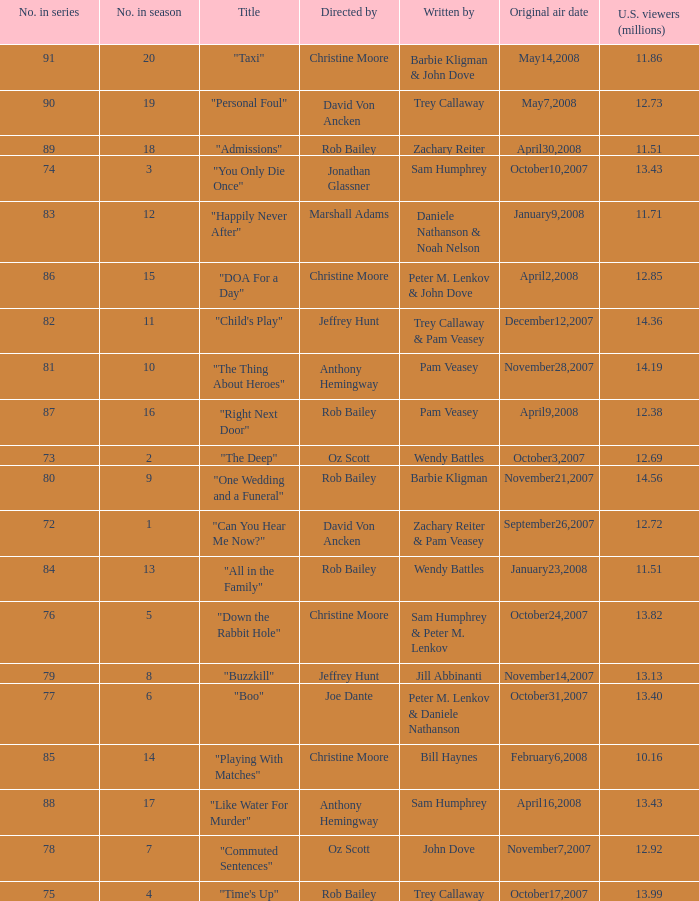How many millions of U.S. viewers watched the episode directed by Rob Bailey and written by Pam Veasey? 12.38. Write the full table. {'header': ['No. in series', 'No. in season', 'Title', 'Directed by', 'Written by', 'Original air date', 'U.S. viewers (millions)'], 'rows': [['91', '20', '"Taxi"', 'Christine Moore', 'Barbie Kligman & John Dove', 'May14,2008', '11.86'], ['90', '19', '"Personal Foul"', 'David Von Ancken', 'Trey Callaway', 'May7,2008', '12.73'], ['89', '18', '"Admissions"', 'Rob Bailey', 'Zachary Reiter', 'April30,2008', '11.51'], ['74', '3', '"You Only Die Once"', 'Jonathan Glassner', 'Sam Humphrey', 'October10,2007', '13.43'], ['83', '12', '"Happily Never After"', 'Marshall Adams', 'Daniele Nathanson & Noah Nelson', 'January9,2008', '11.71'], ['86', '15', '"DOA For a Day"', 'Christine Moore', 'Peter M. Lenkov & John Dove', 'April2,2008', '12.85'], ['82', '11', '"Child\'s Play"', 'Jeffrey Hunt', 'Trey Callaway & Pam Veasey', 'December12,2007', '14.36'], ['81', '10', '"The Thing About Heroes"', 'Anthony Hemingway', 'Pam Veasey', 'November28,2007', '14.19'], ['87', '16', '"Right Next Door"', 'Rob Bailey', 'Pam Veasey', 'April9,2008', '12.38'], ['73', '2', '"The Deep"', 'Oz Scott', 'Wendy Battles', 'October3,2007', '12.69'], ['80', '9', '"One Wedding and a Funeral"', 'Rob Bailey', 'Barbie Kligman', 'November21,2007', '14.56'], ['72', '1', '"Can You Hear Me Now?"', 'David Von Ancken', 'Zachary Reiter & Pam Veasey', 'September26,2007', '12.72'], ['84', '13', '"All in the Family"', 'Rob Bailey', 'Wendy Battles', 'January23,2008', '11.51'], ['76', '5', '"Down the Rabbit Hole"', 'Christine Moore', 'Sam Humphrey & Peter M. Lenkov', 'October24,2007', '13.82'], ['79', '8', '"Buzzkill"', 'Jeffrey Hunt', 'Jill Abbinanti', 'November14,2007', '13.13'], ['77', '6', '"Boo"', 'Joe Dante', 'Peter M. Lenkov & Daniele Nathanson', 'October31,2007', '13.40'], ['85', '14', '"Playing With Matches"', 'Christine Moore', 'Bill Haynes', 'February6,2008', '10.16'], ['88', '17', '"Like Water For Murder"', 'Anthony Hemingway', 'Sam Humphrey', 'April16,2008', '13.43'], ['78', '7', '"Commuted Sentences"', 'Oz Scott', 'John Dove', 'November7,2007', '12.92'], ['75', '4', '"Time\'s Up"', 'Rob Bailey', 'Trey Callaway', 'October17,2007', '13.99']]} 